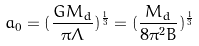<formula> <loc_0><loc_0><loc_500><loc_500>a _ { 0 } = ( \frac { G M _ { d } } { \pi \Lambda } ) ^ { \frac { 1 } { 3 } } = ( \frac { M _ { d } } { 8 \pi ^ { 2 } B } ) ^ { \frac { 1 } { 3 } }</formula> 